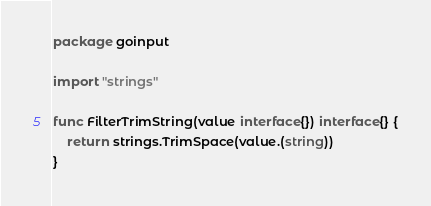<code> <loc_0><loc_0><loc_500><loc_500><_Go_>package goinput

import "strings"

func FilterTrimString(value interface{}) interface{} {
	return strings.TrimSpace(value.(string))
}
</code> 